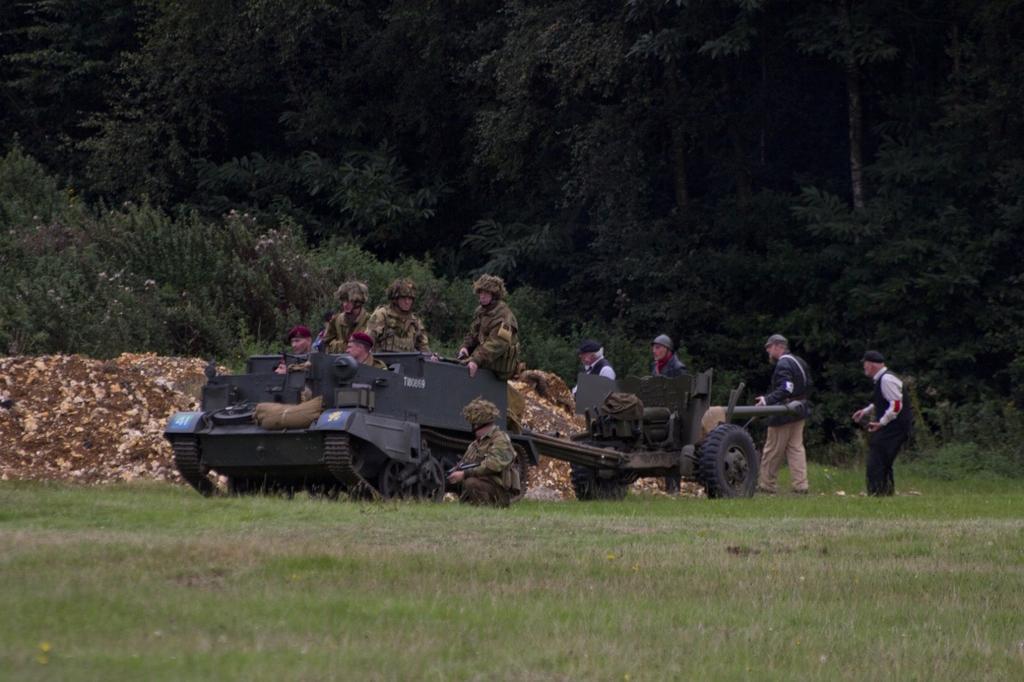In one or two sentences, can you explain what this image depicts? This image is taken in a garden where group of persons are walking and sitting. The persons in the front seems to be a military officials which are sitting in a tank. In a background there are trees, rocks. In the front there is a grass on the floor. There are four persons walking in the background. 